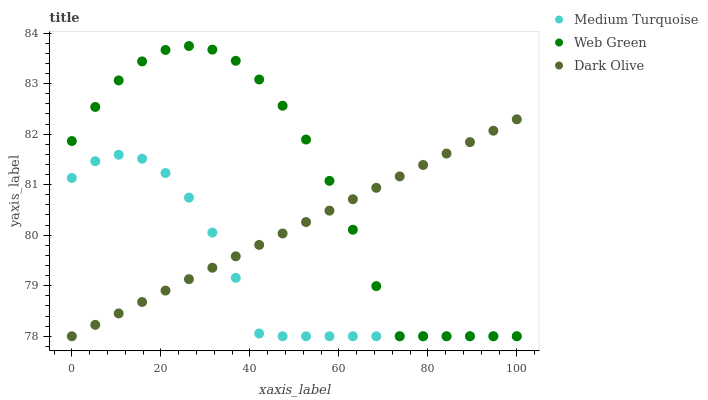Does Medium Turquoise have the minimum area under the curve?
Answer yes or no. Yes. Does Web Green have the maximum area under the curve?
Answer yes or no. Yes. Does Web Green have the minimum area under the curve?
Answer yes or no. No. Does Medium Turquoise have the maximum area under the curve?
Answer yes or no. No. Is Dark Olive the smoothest?
Answer yes or no. Yes. Is Web Green the roughest?
Answer yes or no. Yes. Is Medium Turquoise the smoothest?
Answer yes or no. No. Is Medium Turquoise the roughest?
Answer yes or no. No. Does Dark Olive have the lowest value?
Answer yes or no. Yes. Does Web Green have the highest value?
Answer yes or no. Yes. Does Medium Turquoise have the highest value?
Answer yes or no. No. Does Medium Turquoise intersect Web Green?
Answer yes or no. Yes. Is Medium Turquoise less than Web Green?
Answer yes or no. No. Is Medium Turquoise greater than Web Green?
Answer yes or no. No. 